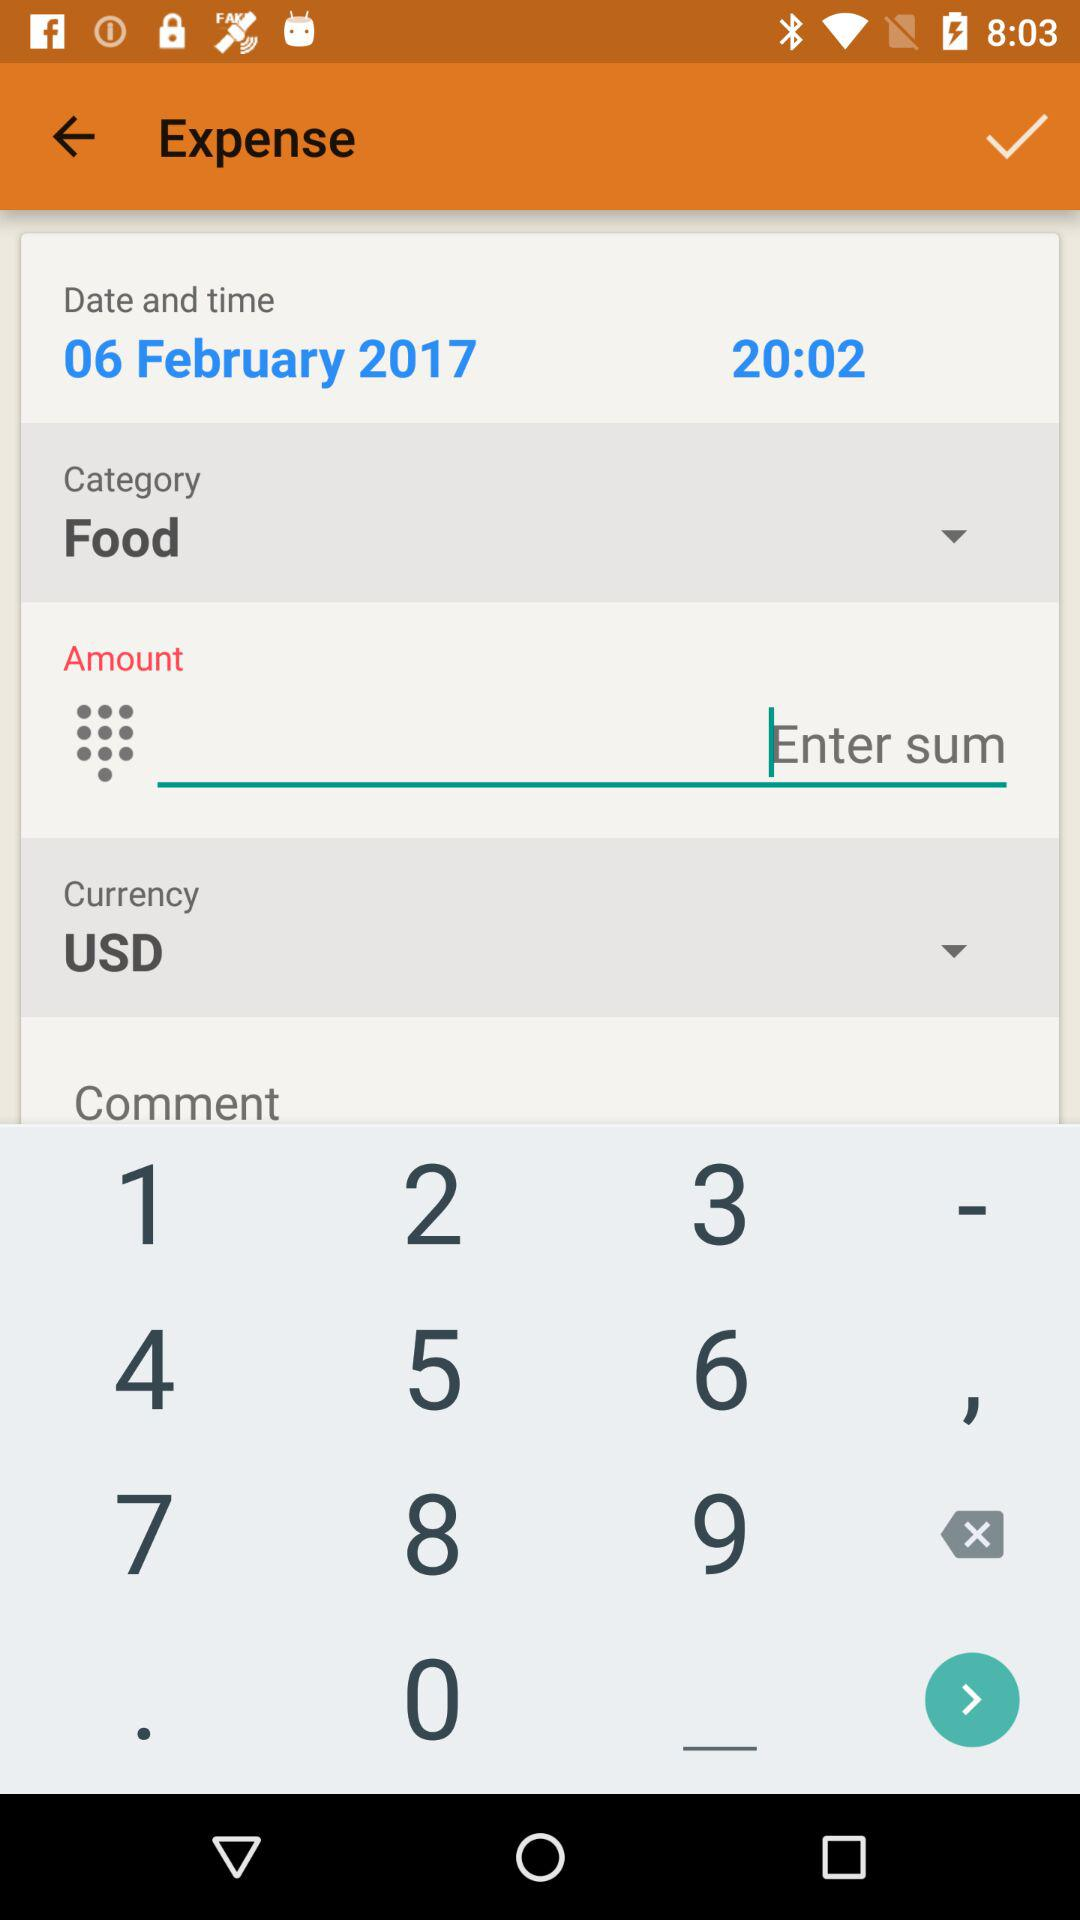Which category is selected? The selected category is "Food". 